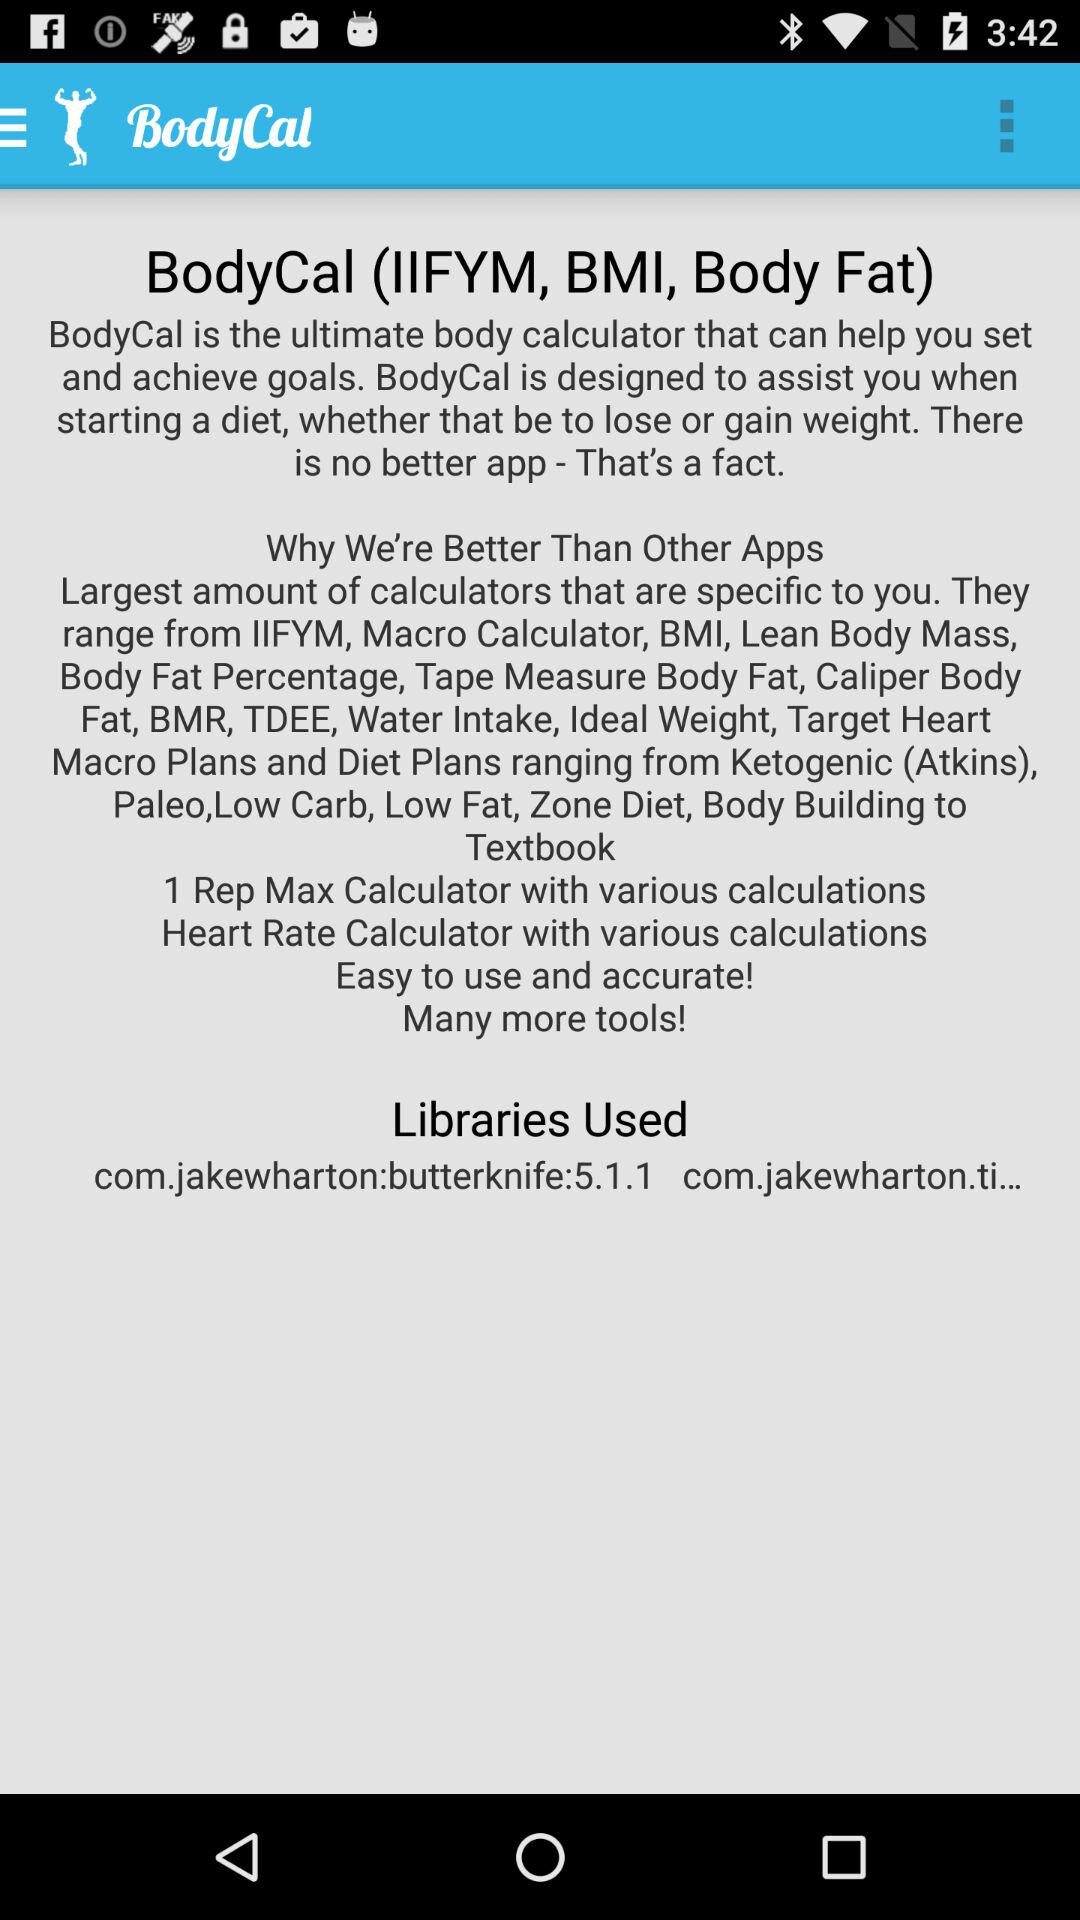What is the application name? The application name is "BodyCal". 